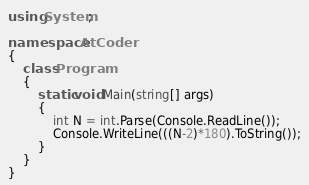Convert code to text. <code><loc_0><loc_0><loc_500><loc_500><_C#_>using System;

namespace AtCoder
{
    class Program
    {
        static void Main(string[] args)
        {
            int N = int.Parse(Console.ReadLine());
            Console.WriteLine(((N-2)*180).ToString());
        }
    }
}
</code> 